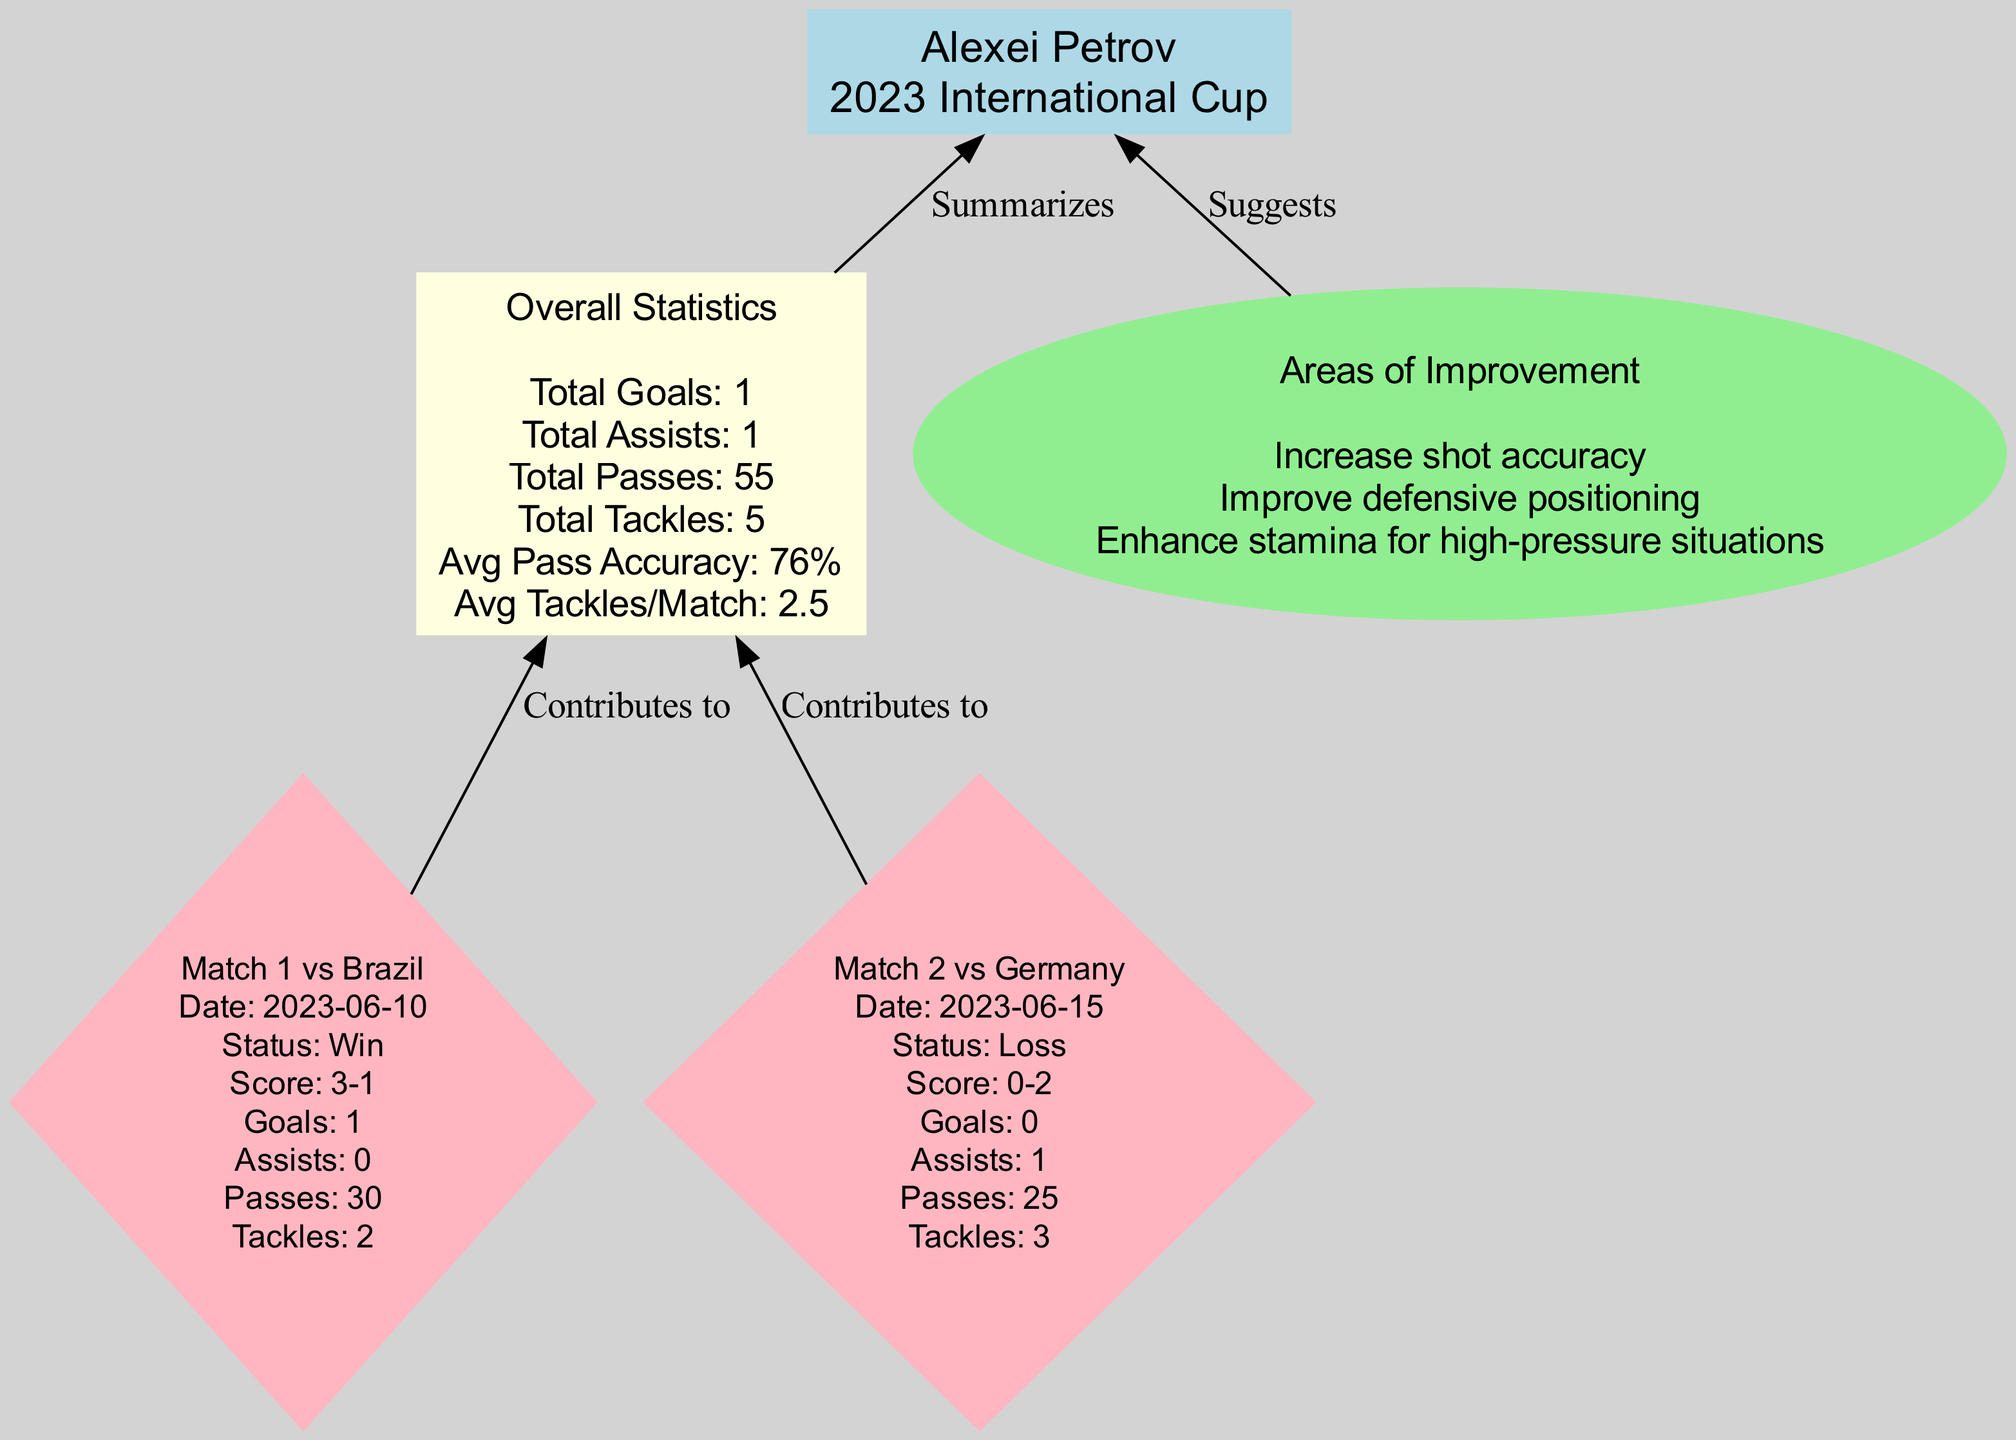What is the player’s name? The diagram identifies the player’s name in the main node at the top of the flowchart, which clearly states "Alexei Petrov."
Answer: Alexei Petrov How many total goals did Alexei score? In the overall statistics section, the total goals are specified as "Total Goals: 1," which indicates the count of goals scored by the player.
Answer: 1 Which opponent did Alexei play against in the second match? The second match details are captured in a diamond-shaped node, which reveals that the opponent was "Germany" in that match.
Answer: Germany What was Alexei's average pass accuracy? The overall statistics node presents relevant metrics, including a section that states "Avg Pass Accuracy: 76%," providing the average pass accuracy value.
Answer: 76% What was the outcome of the match against Brazil? In the matching details node for the first match, the outcome is labeled as "Status: Win," indicating the result of that game.
Answer: Win Which area of improvement mentions enhancing stamina? The areas of improvement section is an ellipse node that lists short phrases. One phrase states "Enhance stamina for high-pressure situations," making it clear this is one of the suggestions.
Answer: Enhance stamina for high-pressure situations How many matches did Alexei play in the tournament? The diagram lists two matches played by Alexei, as indicated by two diamond-shaped nodes corresponding to the two match details.
Answer: 2 Which match contributed to Alexei’s total assists? Referring to the match details, the second match against Germany lists "Assists: 1," indicating this match was the source for the total assists recorded.
Answer: Match 2 What was Alexei's total number of tackles made throughout the tournament? The total tackles are summarized in the overall statistics section, clearly noting "Total Tackles: 5," providing the overall count of tackles made.
Answer: 5 